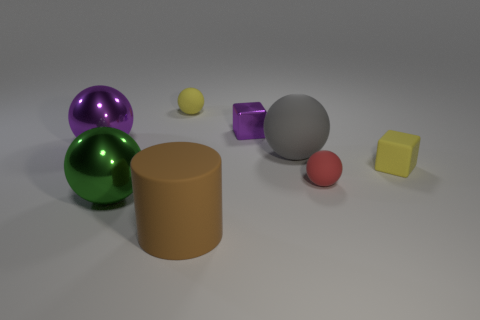What materials do the objects in the image seem to be made of? The green and purple spheres look like they are made from a reflective, glossy material, possibly representing glass or polished metal. The cylindrical object has a matte finish suggesting it might be made of plastic or maybe painted wood. The metallic block looks like it could be made of metal due to its shininess and apparent weight, and the yellow cube has a matte, slightly textured finish, which could indicate a softer material like foam. 